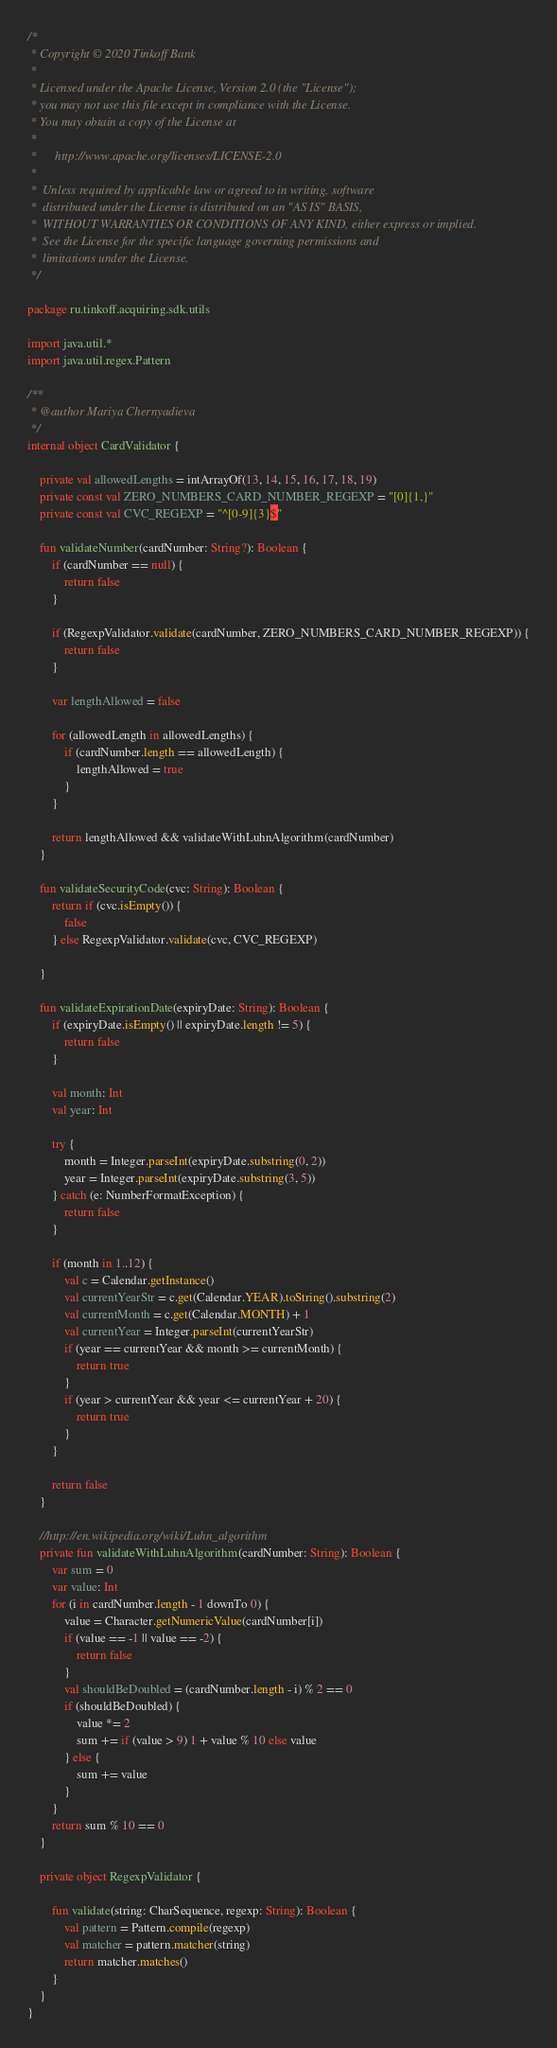<code> <loc_0><loc_0><loc_500><loc_500><_Kotlin_>/*
 * Copyright © 2020 Tinkoff Bank
 *
 * Licensed under the Apache License, Version 2.0 (the "License");
 * you may not use this file except in compliance with the License.
 * You may obtain a copy of the License at
 *
 *      http://www.apache.org/licenses/LICENSE-2.0
 *
 *  Unless required by applicable law or agreed to in writing, software
 *  distributed under the License is distributed on an "AS IS" BASIS,
 *  WITHOUT WARRANTIES OR CONDITIONS OF ANY KIND, either express or implied.
 *  See the License for the specific language governing permissions and
 *  limitations under the License.
 */

package ru.tinkoff.acquiring.sdk.utils

import java.util.*
import java.util.regex.Pattern

/**
 * @author Mariya Chernyadieva
 */
internal object CardValidator {

    private val allowedLengths = intArrayOf(13, 14, 15, 16, 17, 18, 19)
    private const val ZERO_NUMBERS_CARD_NUMBER_REGEXP = "[0]{1,}"
    private const val CVC_REGEXP = "^[0-9]{3}$"

    fun validateNumber(cardNumber: String?): Boolean {
        if (cardNumber == null) {
            return false
        }

        if (RegexpValidator.validate(cardNumber, ZERO_NUMBERS_CARD_NUMBER_REGEXP)) {
            return false
        }

        var lengthAllowed = false

        for (allowedLength in allowedLengths) {
            if (cardNumber.length == allowedLength) {
                lengthAllowed = true
            }
        }

        return lengthAllowed && validateWithLuhnAlgorithm(cardNumber)
    }

    fun validateSecurityCode(cvc: String): Boolean {
        return if (cvc.isEmpty()) {
            false
        } else RegexpValidator.validate(cvc, CVC_REGEXP)

    }

    fun validateExpirationDate(expiryDate: String): Boolean {
        if (expiryDate.isEmpty() || expiryDate.length != 5) {
            return false
        }

        val month: Int
        val year: Int

        try {
            month = Integer.parseInt(expiryDate.substring(0, 2))
            year = Integer.parseInt(expiryDate.substring(3, 5))
        } catch (e: NumberFormatException) {
            return false
        }

        if (month in 1..12) {
            val c = Calendar.getInstance()
            val currentYearStr = c.get(Calendar.YEAR).toString().substring(2)
            val currentMonth = c.get(Calendar.MONTH) + 1
            val currentYear = Integer.parseInt(currentYearStr)
            if (year == currentYear && month >= currentMonth) {
                return true
            }
            if (year > currentYear && year <= currentYear + 20) {
                return true
            }
        }

        return false
    }

    //http://en.wikipedia.org/wiki/Luhn_algorithm
    private fun validateWithLuhnAlgorithm(cardNumber: String): Boolean {
        var sum = 0
        var value: Int
        for (i in cardNumber.length - 1 downTo 0) {
            value = Character.getNumericValue(cardNumber[i])
            if (value == -1 || value == -2) {
                return false
            }
            val shouldBeDoubled = (cardNumber.length - i) % 2 == 0
            if (shouldBeDoubled) {
                value *= 2
                sum += if (value > 9) 1 + value % 10 else value
            } else {
                sum += value
            }
        }
        return sum % 10 == 0
    }

    private object RegexpValidator {

        fun validate(string: CharSequence, regexp: String): Boolean {
            val pattern = Pattern.compile(regexp)
            val matcher = pattern.matcher(string)
            return matcher.matches()
        }
    }
}</code> 